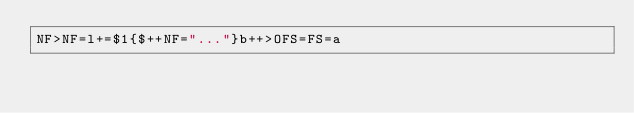<code> <loc_0><loc_0><loc_500><loc_500><_Awk_>NF>NF=l+=$1{$++NF="..."}b++>OFS=FS=a</code> 